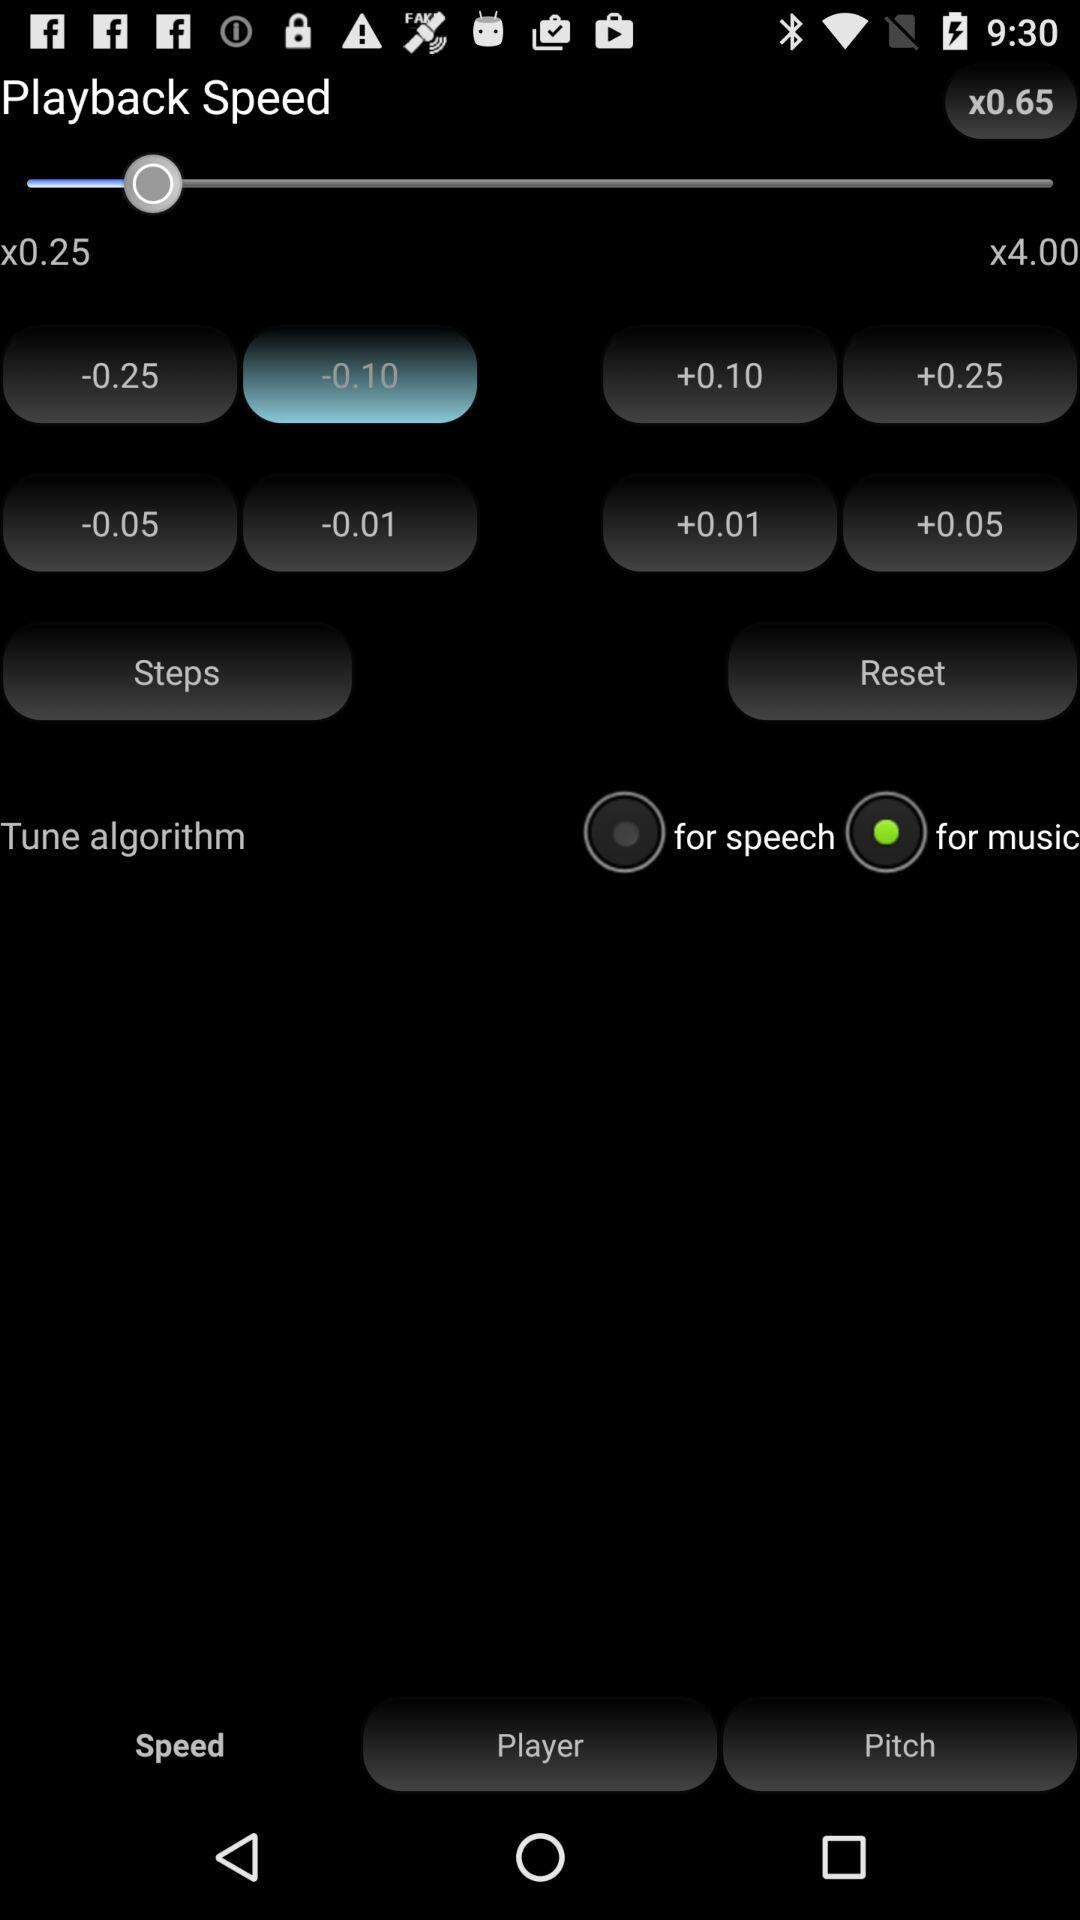Which button is selected? The selected button is "-0.10". 